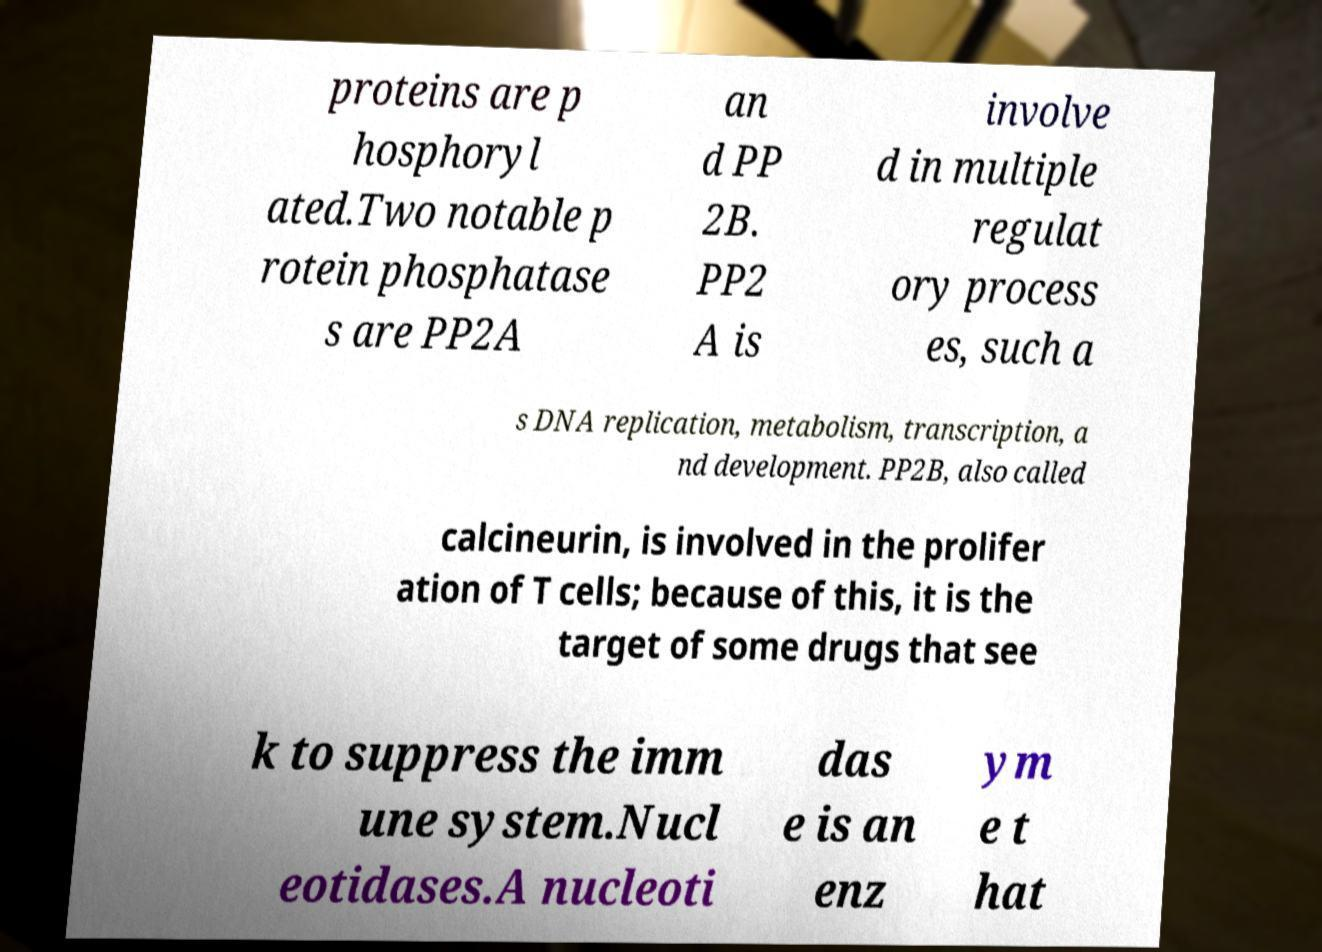I need the written content from this picture converted into text. Can you do that? proteins are p hosphoryl ated.Two notable p rotein phosphatase s are PP2A an d PP 2B. PP2 A is involve d in multiple regulat ory process es, such a s DNA replication, metabolism, transcription, a nd development. PP2B, also called calcineurin, is involved in the prolifer ation of T cells; because of this, it is the target of some drugs that see k to suppress the imm une system.Nucl eotidases.A nucleoti das e is an enz ym e t hat 